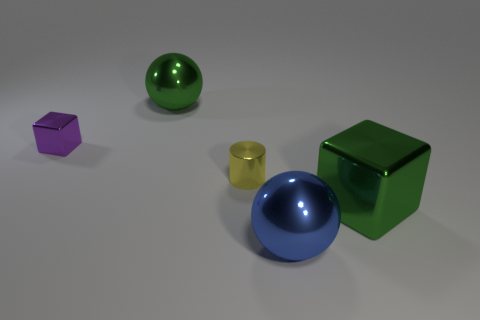Add 2 purple cubes. How many objects exist? 7 Subtract all cubes. How many objects are left? 3 Subtract 0 cyan cylinders. How many objects are left? 5 Subtract all tiny yellow cylinders. Subtract all big green objects. How many objects are left? 2 Add 4 big blue metal balls. How many big blue metal balls are left? 5 Add 2 big blocks. How many big blocks exist? 3 